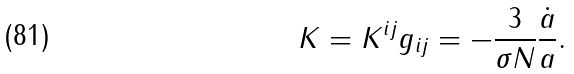<formula> <loc_0><loc_0><loc_500><loc_500>K = K ^ { i j } g _ { i j } = - \frac { 3 } { \sigma N } \frac { \dot { a } } { a } .</formula> 